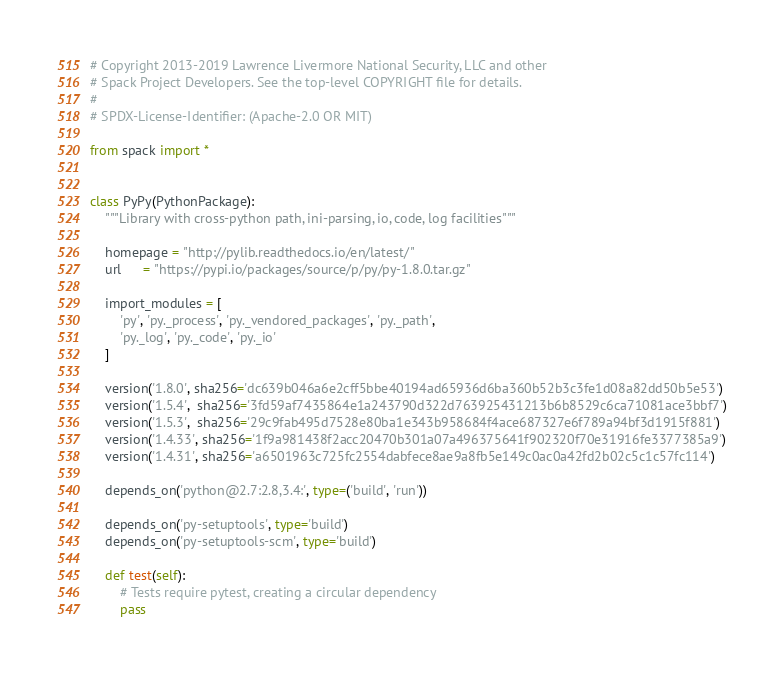<code> <loc_0><loc_0><loc_500><loc_500><_Python_># Copyright 2013-2019 Lawrence Livermore National Security, LLC and other
# Spack Project Developers. See the top-level COPYRIGHT file for details.
#
# SPDX-License-Identifier: (Apache-2.0 OR MIT)

from spack import *


class PyPy(PythonPackage):
    """Library with cross-python path, ini-parsing, io, code, log facilities"""

    homepage = "http://pylib.readthedocs.io/en/latest/"
    url      = "https://pypi.io/packages/source/p/py/py-1.8.0.tar.gz"

    import_modules = [
        'py', 'py._process', 'py._vendored_packages', 'py._path',
        'py._log', 'py._code', 'py._io'
    ]

    version('1.8.0', sha256='dc639b046a6e2cff5bbe40194ad65936d6ba360b52b3c3fe1d08a82dd50b5e53')
    version('1.5.4',  sha256='3fd59af7435864e1a243790d322d763925431213b6b8529c6ca71081ace3bbf7')
    version('1.5.3',  sha256='29c9fab495d7528e80ba1e343b958684f4ace687327e6f789a94bf3d1915f881')
    version('1.4.33', sha256='1f9a981438f2acc20470b301a07a496375641f902320f70e31916fe3377385a9')
    version('1.4.31', sha256='a6501963c725fc2554dabfece8ae9a8fb5e149c0ac0a42fd2b02c5c1c57fc114')

    depends_on('python@2.7:2.8,3.4:', type=('build', 'run'))

    depends_on('py-setuptools', type='build')
    depends_on('py-setuptools-scm', type='build')

    def test(self):
        # Tests require pytest, creating a circular dependency
        pass
</code> 